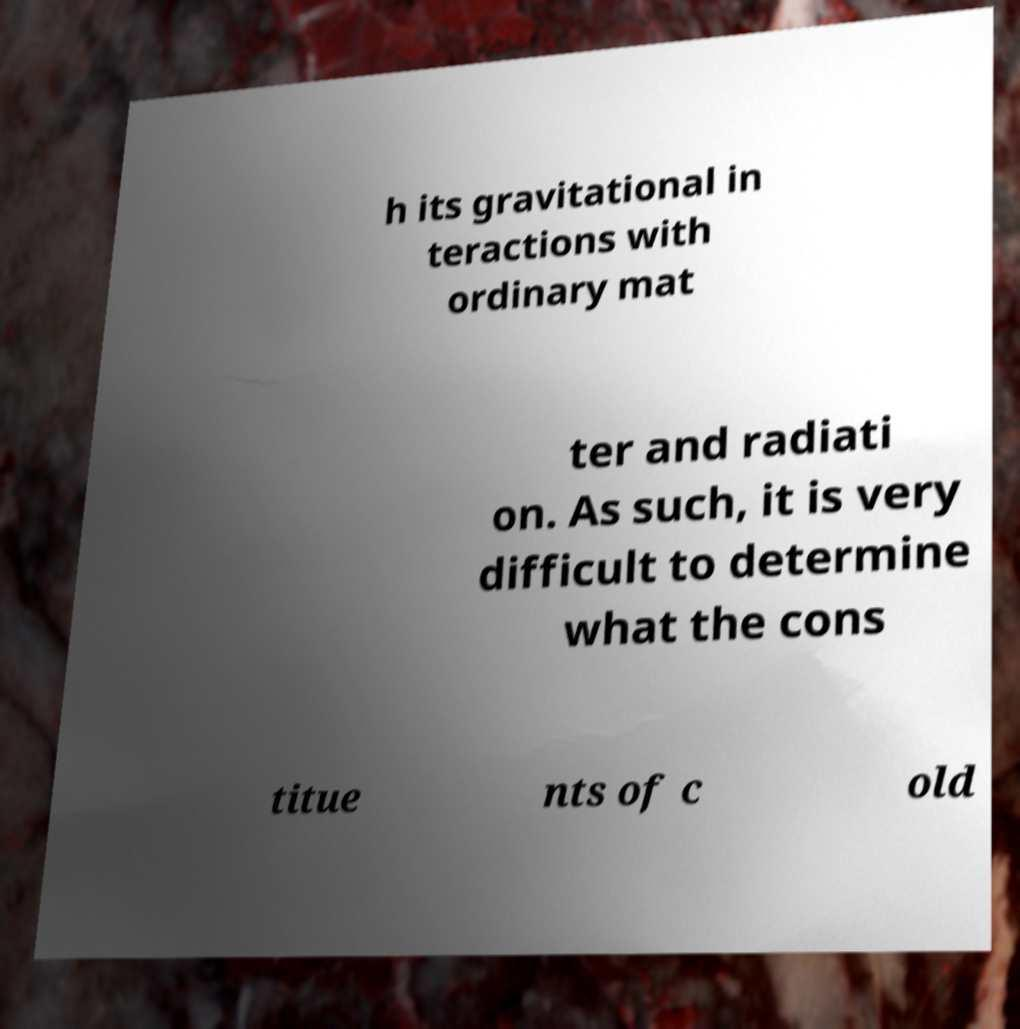Could you extract and type out the text from this image? h its gravitational in teractions with ordinary mat ter and radiati on. As such, it is very difficult to determine what the cons titue nts of c old 